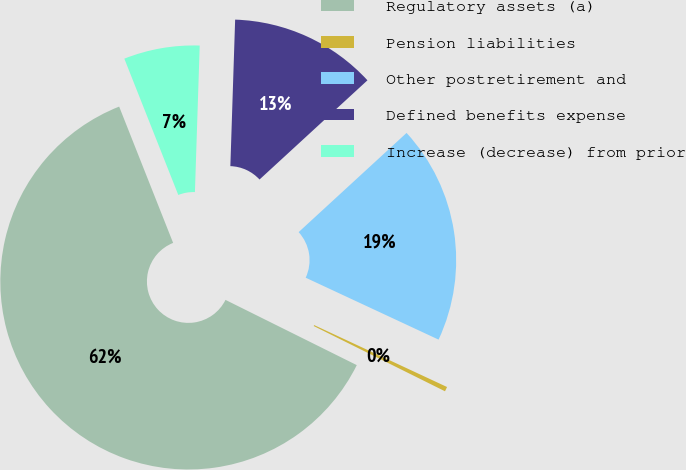<chart> <loc_0><loc_0><loc_500><loc_500><pie_chart><fcel>Regulatory assets (a)<fcel>Pension liabilities<fcel>Other postretirement and<fcel>Defined benefits expense<fcel>Increase (decrease) from prior<nl><fcel>61.66%<fcel>0.4%<fcel>18.77%<fcel>12.65%<fcel>6.52%<nl></chart> 